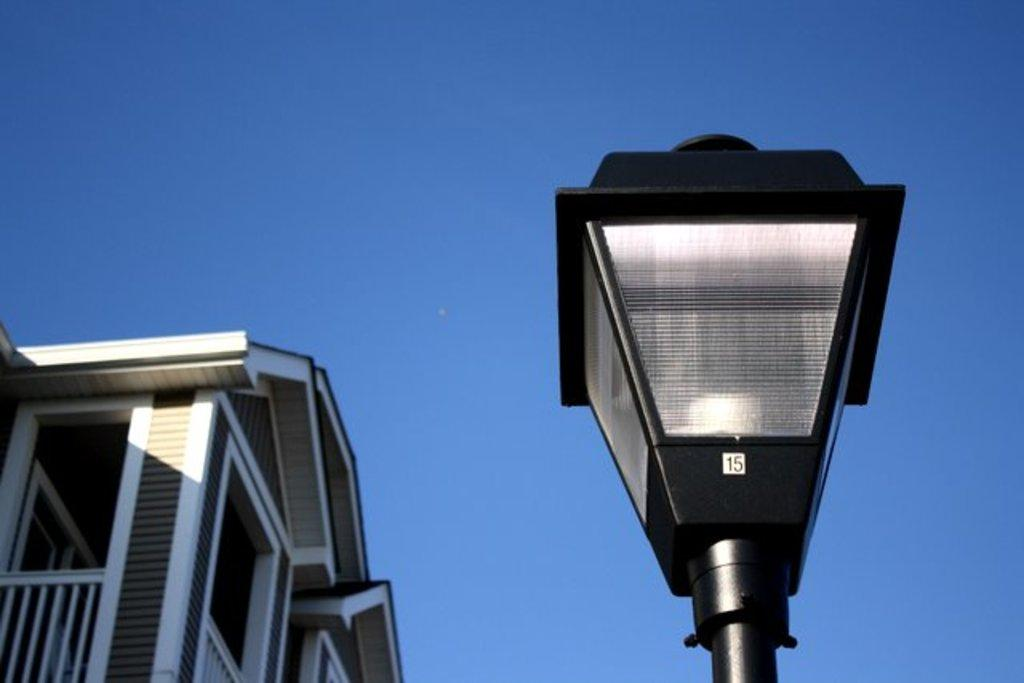What structure can be seen on the right side of the image? There is a decorative light pole on the right side of the image. What is located on the left side of the image? There is a building on the left side of the image. What color is the sky in the image? The sky is blue in the image. What type of pets are visible in the image? There are no pets present in the image. What is being served for lunch in the image? There is no reference to lunch or any food in the image. 